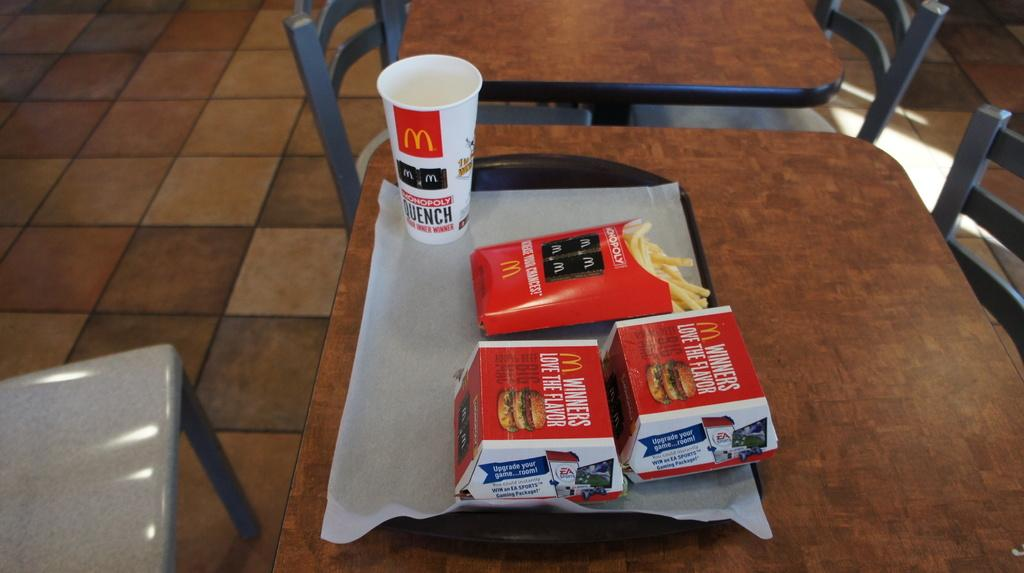What type of furniture is visible in the image? There are tables and chairs in the image. Where are the tables and chairs located? The tables and chairs are on the floor. What is in the middle of the image? There is a plate in the middle of the image. What items can be found on the plate? The plate contains boxes, paper, and a cup. Can you see a boat in the image? No, there is no boat present in the image. What type of pencil is being used to write on the paper in the image? There is no pencil visible in the image, as the paper is empty. 